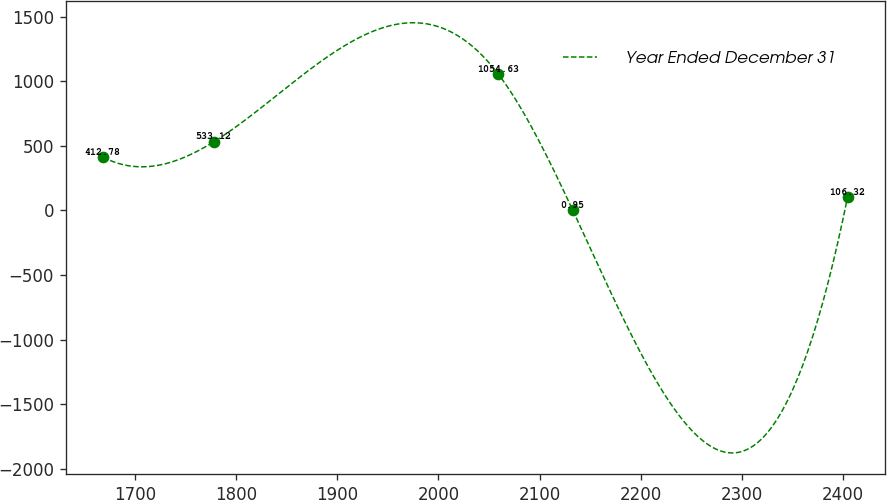<chart> <loc_0><loc_0><loc_500><loc_500><line_chart><ecel><fcel>Year Ended December 31<nl><fcel>1668.16<fcel>412.78<nl><fcel>1778.22<fcel>533.12<nl><fcel>2059.21<fcel>1054.63<nl><fcel>2132.87<fcel>0.95<nl><fcel>2404.72<fcel>106.32<nl></chart> 